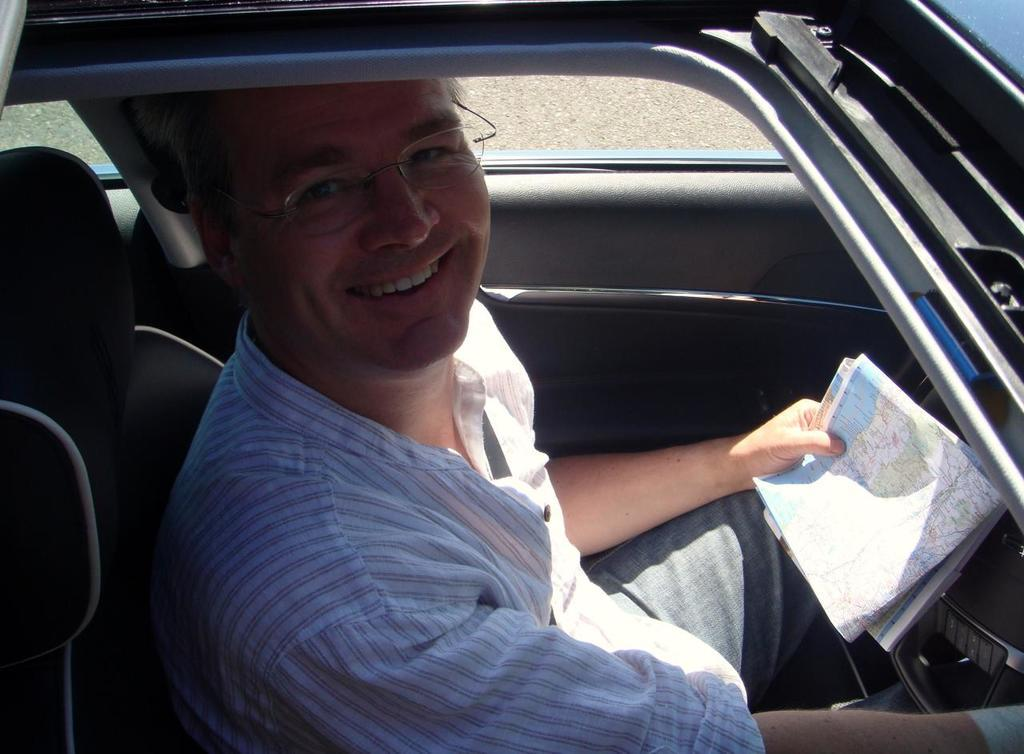What is the person in the image doing? The person in the image is holding a map. Where is the person located in the image? The person is sitting inside a vehicle. What is the status of the vehicle in the image? The vehicle is parked on the ground. What type of butter is being used to grease the arch in the image? There is no butter or arch present in the image. How many beans are visible on the person's lap in the image? There are no beans visible in the image. 